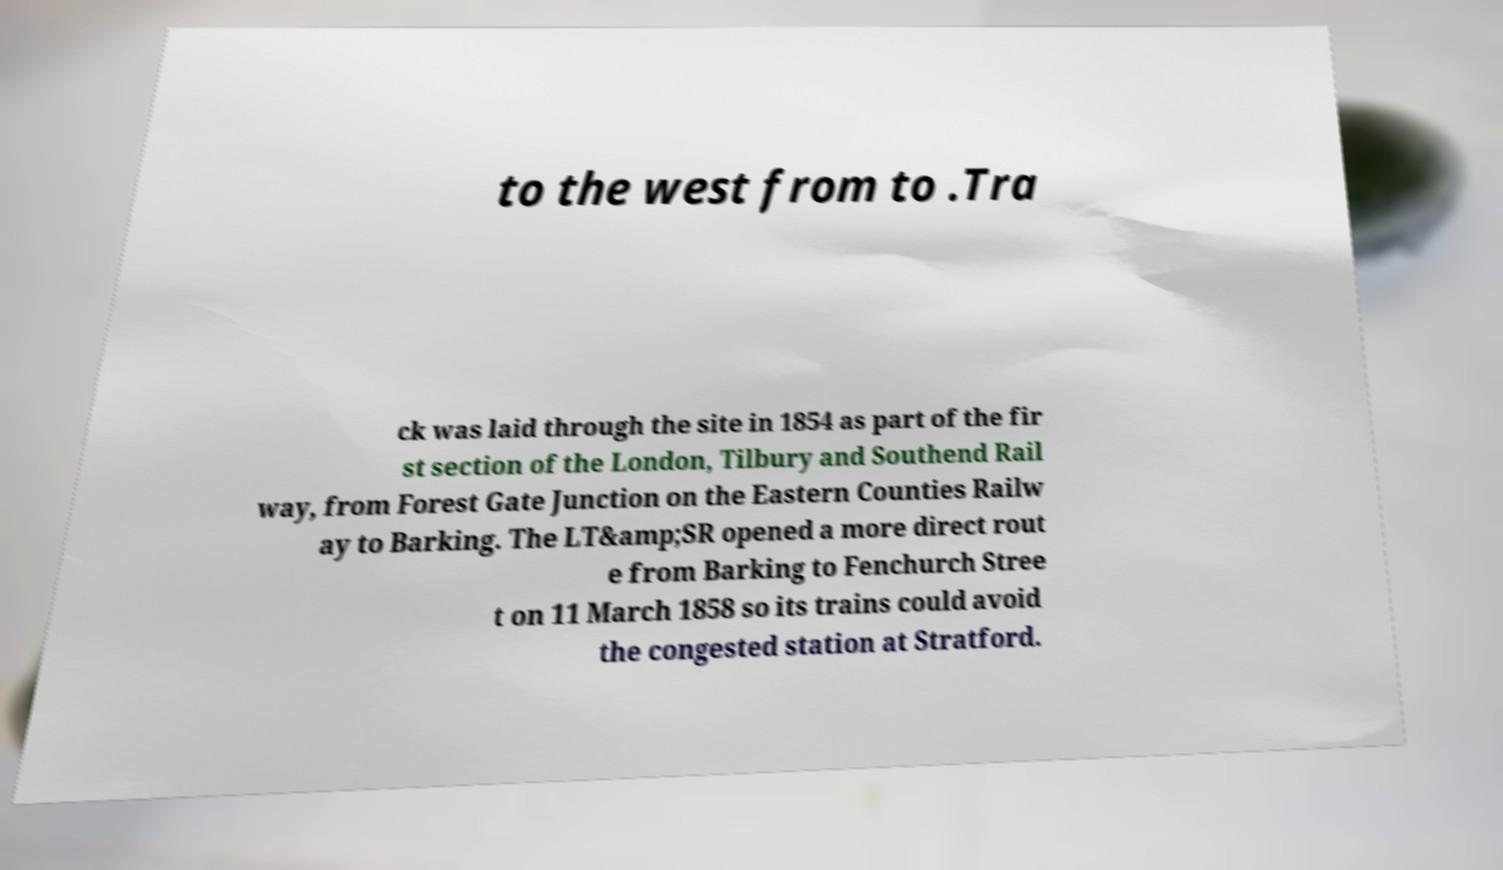Could you extract and type out the text from this image? to the west from to .Tra ck was laid through the site in 1854 as part of the fir st section of the London, Tilbury and Southend Rail way, from Forest Gate Junction on the Eastern Counties Railw ay to Barking. The LT&amp;SR opened a more direct rout e from Barking to Fenchurch Stree t on 11 March 1858 so its trains could avoid the congested station at Stratford. 